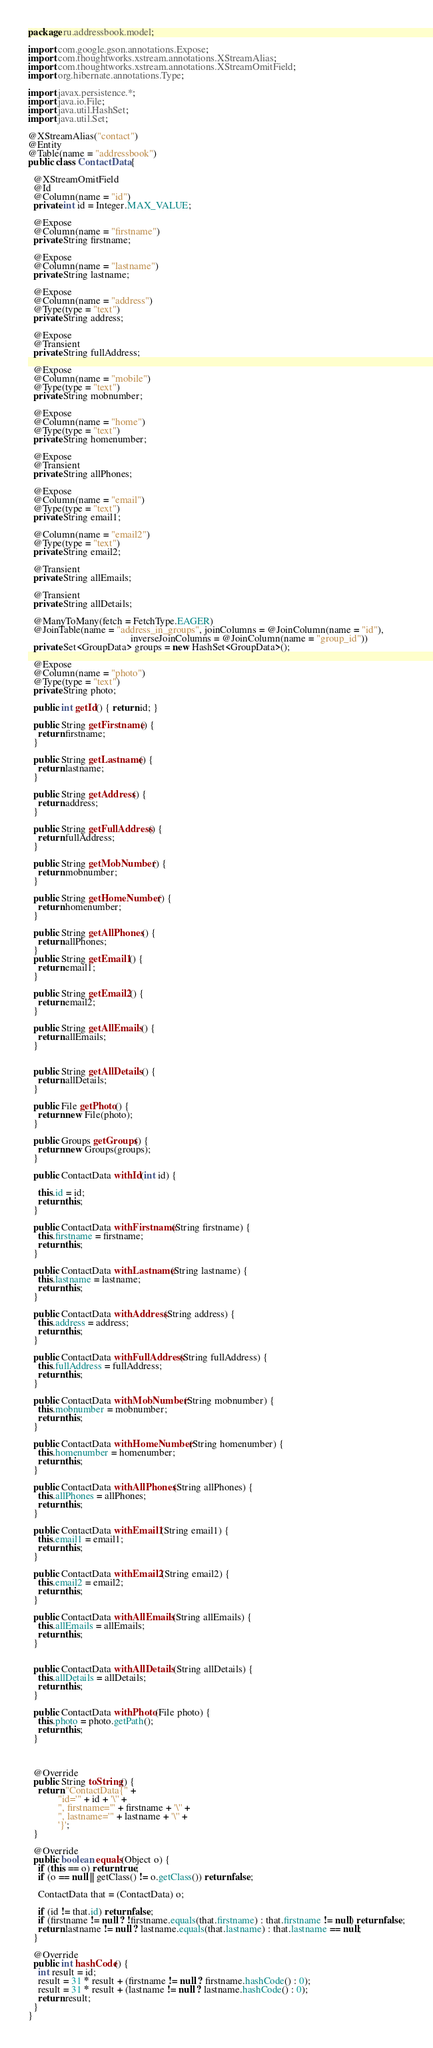<code> <loc_0><loc_0><loc_500><loc_500><_Java_>package ru.addressbook.model;

import com.google.gson.annotations.Expose;
import com.thoughtworks.xstream.annotations.XStreamAlias;
import com.thoughtworks.xstream.annotations.XStreamOmitField;
import org.hibernate.annotations.Type;

import javax.persistence.*;
import java.io.File;
import java.util.HashSet;
import java.util.Set;

@XStreamAlias("contact")
@Entity
@Table(name = "addressbook")
public class ContactData {

  @XStreamOmitField
  @Id
  @Column(name = "id")
  private int id = Integer.MAX_VALUE;

  @Expose
  @Column(name = "firstname")
  private String firstname;

  @Expose
  @Column(name = "lastname")
  private String lastname;

  @Expose
  @Column(name = "address")
  @Type(type = "text")
  private String address;

  @Expose
  @Transient
  private String fullAddress;

  @Expose
  @Column(name = "mobile")
  @Type(type = "text")
  private String mobnumber;

  @Expose
  @Column(name = "home")
  @Type(type = "text")
  private String homenumber;

  @Expose
  @Transient
  private String allPhones;

  @Expose
  @Column(name = "email")
  @Type(type = "text")
  private String email1;

  @Column(name = "email2")
  @Type(type = "text")
  private String email2;

  @Transient
  private String allEmails;

  @Transient
  private String allDetails;

  @ManyToMany(fetch = FetchType.EAGER)
  @JoinTable(name = "address_in_groups", joinColumns = @JoinColumn(name = "id"),
                                         inverseJoinColumns = @JoinColumn(name = "group_id"))
  private Set<GroupData> groups = new HashSet<GroupData>();

  @Expose
  @Column(name = "photo")
  @Type(type = "text")
  private String photo;

  public int getId() { return id; }

  public String getFirstname() {
    return firstname;
  }

  public String getLastname() {
    return lastname;
  }

  public String getAddress() {
    return address;
  }

  public String getFullAddress() {
    return fullAddress;
  }

  public String getMobNumber() {
    return mobnumber;
  }

  public String getHomeNumber() {
    return homenumber;
  }

  public String getAllPhones() {
    return allPhones;
  }
  public String getEmail1() {
    return email1;
  }

  public String getEmail2() {
    return email2;
  }

  public String getAllEmails() {
    return allEmails;
  }


  public String getAllDetails() {
    return allDetails;
  }

  public File getPhoto() {
    return new File(photo);
  }

  public Groups getGroups() {
    return new Groups(groups);
  }

  public ContactData withId(int id) {

    this.id = id;
    return this;
  }

  public ContactData withFirstname(String firstname) {
    this.firstname = firstname;
    return this;
  }

  public ContactData withLastname(String lastname) {
    this.lastname = lastname;
    return this;
  }

  public ContactData withAddress(String address) {
    this.address = address;
    return this;
  }

  public ContactData withFullAddress(String fullAddress) {
    this.fullAddress = fullAddress;
    return this;
  }

  public ContactData withMobNumber(String mobnumber) {
    this.mobnumber = mobnumber;
    return this;
  }

  public ContactData withHomeNumber(String homenumber) {
    this.homenumber = homenumber;
    return this;
  }

  public ContactData withAllPhones(String allPhones) {
    this.allPhones = allPhones;
    return this;
  }

  public ContactData withEmail1(String email1) {
    this.email1 = email1;
    return this;
  }

  public ContactData withEmail2(String email2) {
    this.email2 = email2;
    return this;
  }

  public ContactData withAllEmails(String allEmails) {
    this.allEmails = allEmails;
    return this;
  }


  public ContactData withAllDetails(String allDetails) {
    this.allDetails = allDetails;
    return this;
  }

  public ContactData withPhoto(File photo) {
    this.photo = photo.getPath();
    return this;
  }



  @Override
  public String toString() {
    return "ContactData{" +
            "id='" + id + '\'' +
            ", firstname='" + firstname + '\'' +
            ", lastname='" + lastname + '\'' +
            '}';
  }

  @Override
  public boolean equals(Object o) {
    if (this == o) return true;
    if (o == null || getClass() != o.getClass()) return false;

    ContactData that = (ContactData) o;

    if (id != that.id) return false;
    if (firstname != null ? !firstname.equals(that.firstname) : that.firstname != null) return false;
    return lastname != null ? lastname.equals(that.lastname) : that.lastname == null;
  }

  @Override
  public int hashCode() {
    int result = id;
    result = 31 * result + (firstname != null ? firstname.hashCode() : 0);
    result = 31 * result + (lastname != null ? lastname.hashCode() : 0);
    return result;
  }
}
</code> 